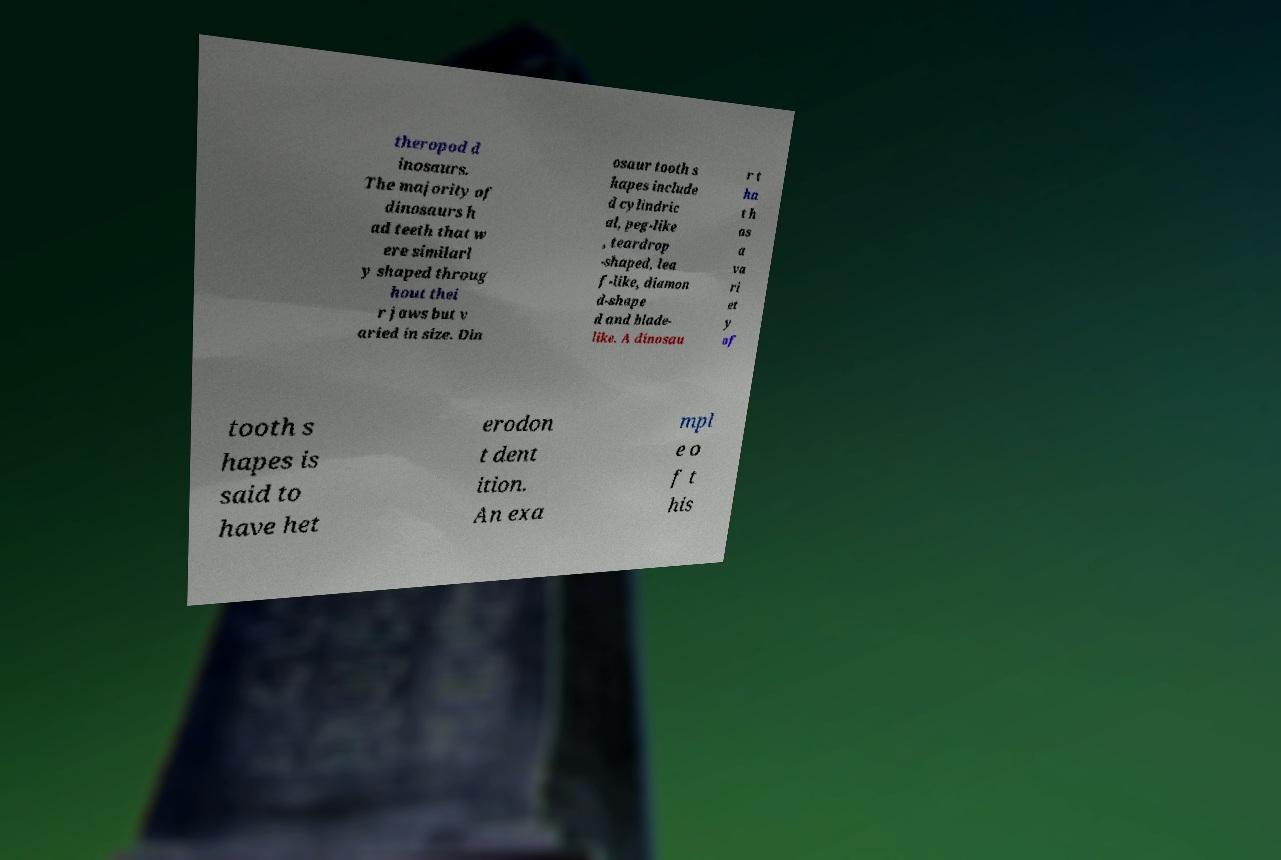Could you extract and type out the text from this image? theropod d inosaurs. The majority of dinosaurs h ad teeth that w ere similarl y shaped throug hout thei r jaws but v aried in size. Din osaur tooth s hapes include d cylindric al, peg-like , teardrop -shaped, lea f-like, diamon d-shape d and blade- like. A dinosau r t ha t h as a va ri et y of tooth s hapes is said to have het erodon t dent ition. An exa mpl e o f t his 